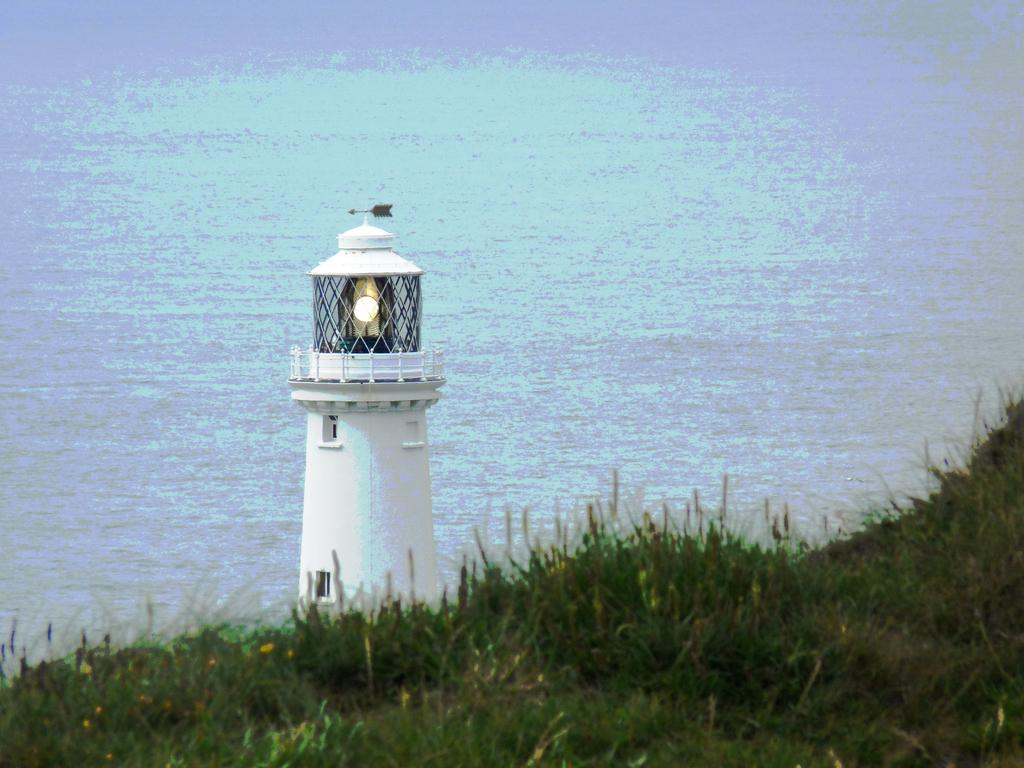What type of surface is visible in the image? There is grass on the surface in the image. What structure is located in the center of the image? There is a lighthouse in the center of the image. What can be seen in the background of the image? There is water visible in the background of the image. Where is the gun hidden in the image? There is no gun present in the image. What type of plant is growing near the lighthouse in the image? The image does not specify any particular type of plant growing near the lighthouse, only that there is grass on the surface. 